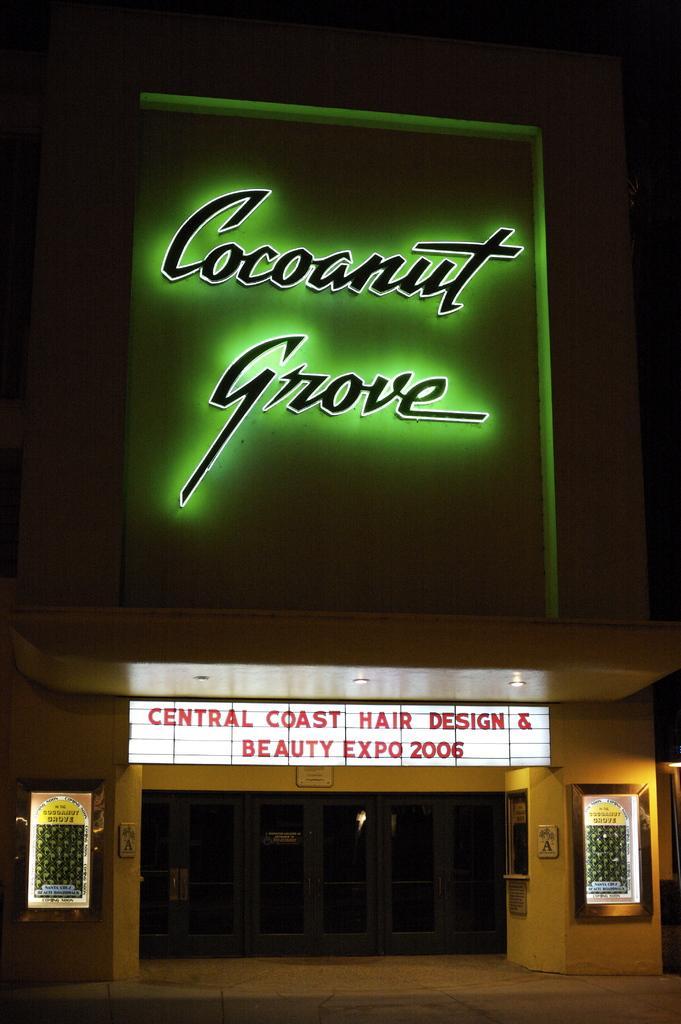Can you describe this image briefly? In this image I can see the building and there are many led boards to the building. And there is a black background. 